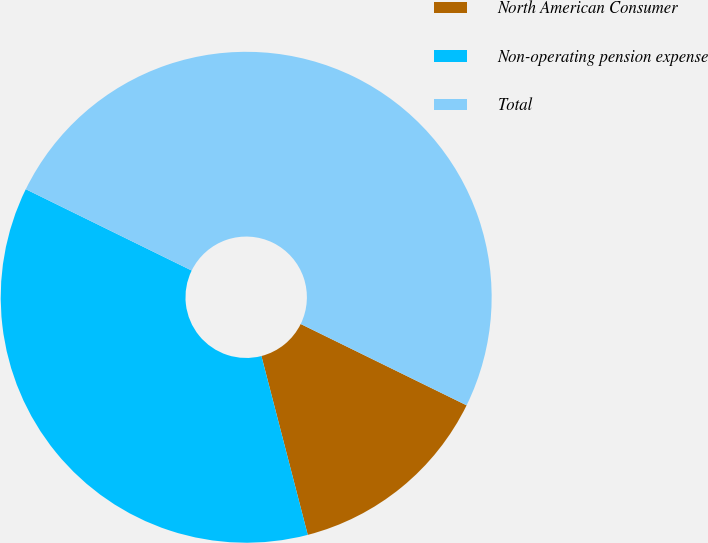Convert chart. <chart><loc_0><loc_0><loc_500><loc_500><pie_chart><fcel>North American Consumer<fcel>Non-operating pension expense<fcel>Total<nl><fcel>13.71%<fcel>36.29%<fcel>50.0%<nl></chart> 